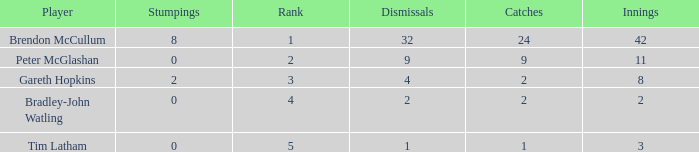List the ranks of all dismissals with a value of 4 3.0. 